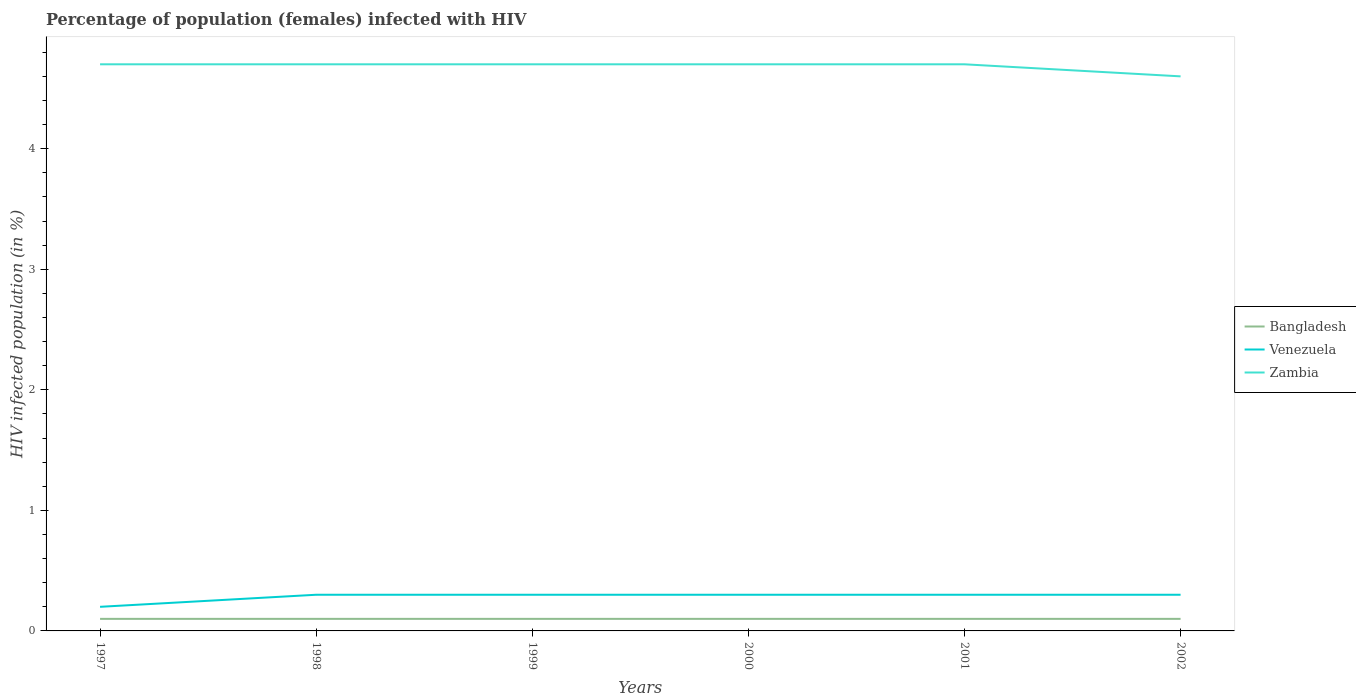How many different coloured lines are there?
Provide a succinct answer. 3. Is the number of lines equal to the number of legend labels?
Make the answer very short. Yes. Across all years, what is the maximum percentage of HIV infected female population in Venezuela?
Your response must be concise. 0.2. What is the total percentage of HIV infected female population in Venezuela in the graph?
Offer a very short reply. 0. What is the difference between the highest and the second highest percentage of HIV infected female population in Venezuela?
Ensure brevity in your answer.  0.1. Is the percentage of HIV infected female population in Venezuela strictly greater than the percentage of HIV infected female population in Bangladesh over the years?
Provide a short and direct response. No. How many years are there in the graph?
Offer a terse response. 6. Are the values on the major ticks of Y-axis written in scientific E-notation?
Give a very brief answer. No. Does the graph contain any zero values?
Offer a terse response. No. Does the graph contain grids?
Provide a succinct answer. No. How are the legend labels stacked?
Offer a very short reply. Vertical. What is the title of the graph?
Provide a short and direct response. Percentage of population (females) infected with HIV. Does "Cyprus" appear as one of the legend labels in the graph?
Make the answer very short. No. What is the label or title of the X-axis?
Your answer should be compact. Years. What is the label or title of the Y-axis?
Offer a terse response. HIV infected population (in %). What is the HIV infected population (in %) of Zambia in 1997?
Your response must be concise. 4.7. What is the HIV infected population (in %) of Bangladesh in 1998?
Your answer should be compact. 0.1. What is the HIV infected population (in %) in Zambia in 1998?
Offer a terse response. 4.7. What is the HIV infected population (in %) in Venezuela in 1999?
Give a very brief answer. 0.3. What is the HIV infected population (in %) in Zambia in 1999?
Ensure brevity in your answer.  4.7. What is the HIV infected population (in %) of Zambia in 2000?
Your response must be concise. 4.7. What is the HIV infected population (in %) in Bangladesh in 2001?
Your answer should be very brief. 0.1. What is the HIV infected population (in %) in Zambia in 2001?
Provide a short and direct response. 4.7. What is the HIV infected population (in %) in Venezuela in 2002?
Provide a short and direct response. 0.3. Across all years, what is the maximum HIV infected population (in %) in Bangladesh?
Provide a short and direct response. 0.1. Across all years, what is the maximum HIV infected population (in %) of Venezuela?
Your answer should be compact. 0.3. Across all years, what is the maximum HIV infected population (in %) of Zambia?
Offer a very short reply. 4.7. Across all years, what is the minimum HIV infected population (in %) in Bangladesh?
Your response must be concise. 0.1. Across all years, what is the minimum HIV infected population (in %) of Venezuela?
Give a very brief answer. 0.2. What is the total HIV infected population (in %) in Bangladesh in the graph?
Your answer should be compact. 0.6. What is the total HIV infected population (in %) of Zambia in the graph?
Ensure brevity in your answer.  28.1. What is the difference between the HIV infected population (in %) of Venezuela in 1997 and that in 1998?
Make the answer very short. -0.1. What is the difference between the HIV infected population (in %) in Zambia in 1997 and that in 1998?
Your answer should be compact. 0. What is the difference between the HIV infected population (in %) of Bangladesh in 1997 and that in 1999?
Your response must be concise. 0. What is the difference between the HIV infected population (in %) in Bangladesh in 1997 and that in 2000?
Keep it short and to the point. 0. What is the difference between the HIV infected population (in %) of Venezuela in 1997 and that in 2000?
Offer a terse response. -0.1. What is the difference between the HIV infected population (in %) in Bangladesh in 1997 and that in 2001?
Offer a very short reply. 0. What is the difference between the HIV infected population (in %) of Zambia in 1997 and that in 2001?
Provide a short and direct response. 0. What is the difference between the HIV infected population (in %) of Bangladesh in 1997 and that in 2002?
Provide a short and direct response. 0. What is the difference between the HIV infected population (in %) in Venezuela in 1997 and that in 2002?
Your answer should be very brief. -0.1. What is the difference between the HIV infected population (in %) in Zambia in 1997 and that in 2002?
Your response must be concise. 0.1. What is the difference between the HIV infected population (in %) in Bangladesh in 1998 and that in 1999?
Ensure brevity in your answer.  0. What is the difference between the HIV infected population (in %) of Venezuela in 1998 and that in 1999?
Offer a terse response. 0. What is the difference between the HIV infected population (in %) in Bangladesh in 1998 and that in 2000?
Give a very brief answer. 0. What is the difference between the HIV infected population (in %) in Zambia in 1998 and that in 2000?
Offer a terse response. 0. What is the difference between the HIV infected population (in %) in Venezuela in 1998 and that in 2001?
Ensure brevity in your answer.  0. What is the difference between the HIV infected population (in %) of Zambia in 1998 and that in 2001?
Offer a terse response. 0. What is the difference between the HIV infected population (in %) in Venezuela in 1998 and that in 2002?
Ensure brevity in your answer.  0. What is the difference between the HIV infected population (in %) of Zambia in 1998 and that in 2002?
Offer a terse response. 0.1. What is the difference between the HIV infected population (in %) in Bangladesh in 1999 and that in 2002?
Ensure brevity in your answer.  0. What is the difference between the HIV infected population (in %) of Venezuela in 1999 and that in 2002?
Your answer should be very brief. 0. What is the difference between the HIV infected population (in %) in Zambia in 2000 and that in 2002?
Make the answer very short. 0.1. What is the difference between the HIV infected population (in %) of Venezuela in 2001 and that in 2002?
Provide a short and direct response. 0. What is the difference between the HIV infected population (in %) of Bangladesh in 1997 and the HIV infected population (in %) of Venezuela in 1998?
Keep it short and to the point. -0.2. What is the difference between the HIV infected population (in %) in Venezuela in 1997 and the HIV infected population (in %) in Zambia in 1998?
Provide a short and direct response. -4.5. What is the difference between the HIV infected population (in %) of Bangladesh in 1997 and the HIV infected population (in %) of Venezuela in 1999?
Provide a short and direct response. -0.2. What is the difference between the HIV infected population (in %) of Bangladesh in 1997 and the HIV infected population (in %) of Venezuela in 2000?
Ensure brevity in your answer.  -0.2. What is the difference between the HIV infected population (in %) of Bangladesh in 1997 and the HIV infected population (in %) of Zambia in 2001?
Your answer should be compact. -4.6. What is the difference between the HIV infected population (in %) of Venezuela in 1997 and the HIV infected population (in %) of Zambia in 2002?
Make the answer very short. -4.4. What is the difference between the HIV infected population (in %) of Bangladesh in 1998 and the HIV infected population (in %) of Venezuela in 1999?
Offer a very short reply. -0.2. What is the difference between the HIV infected population (in %) of Venezuela in 1998 and the HIV infected population (in %) of Zambia in 1999?
Your answer should be very brief. -4.4. What is the difference between the HIV infected population (in %) in Bangladesh in 1998 and the HIV infected population (in %) in Zambia in 2000?
Your answer should be very brief. -4.6. What is the difference between the HIV infected population (in %) in Bangladesh in 1998 and the HIV infected population (in %) in Zambia in 2001?
Provide a short and direct response. -4.6. What is the difference between the HIV infected population (in %) of Venezuela in 1998 and the HIV infected population (in %) of Zambia in 2001?
Provide a short and direct response. -4.4. What is the difference between the HIV infected population (in %) of Bangladesh in 1998 and the HIV infected population (in %) of Zambia in 2002?
Provide a succinct answer. -4.5. What is the difference between the HIV infected population (in %) of Bangladesh in 1999 and the HIV infected population (in %) of Venezuela in 2002?
Your answer should be compact. -0.2. What is the difference between the HIV infected population (in %) in Bangladesh in 1999 and the HIV infected population (in %) in Zambia in 2002?
Give a very brief answer. -4.5. What is the difference between the HIV infected population (in %) of Venezuela in 1999 and the HIV infected population (in %) of Zambia in 2002?
Your answer should be very brief. -4.3. What is the difference between the HIV infected population (in %) of Bangladesh in 2000 and the HIV infected population (in %) of Zambia in 2001?
Provide a succinct answer. -4.6. What is the difference between the HIV infected population (in %) in Venezuela in 2000 and the HIV infected population (in %) in Zambia in 2001?
Provide a succinct answer. -4.4. What is the difference between the HIV infected population (in %) of Bangladesh in 2001 and the HIV infected population (in %) of Venezuela in 2002?
Provide a succinct answer. -0.2. What is the difference between the HIV infected population (in %) in Venezuela in 2001 and the HIV infected population (in %) in Zambia in 2002?
Make the answer very short. -4.3. What is the average HIV infected population (in %) of Bangladesh per year?
Provide a succinct answer. 0.1. What is the average HIV infected population (in %) of Venezuela per year?
Ensure brevity in your answer.  0.28. What is the average HIV infected population (in %) of Zambia per year?
Provide a short and direct response. 4.68. In the year 1997, what is the difference between the HIV infected population (in %) of Bangladesh and HIV infected population (in %) of Venezuela?
Your answer should be compact. -0.1. In the year 1997, what is the difference between the HIV infected population (in %) of Venezuela and HIV infected population (in %) of Zambia?
Make the answer very short. -4.5. In the year 1998, what is the difference between the HIV infected population (in %) of Bangladesh and HIV infected population (in %) of Venezuela?
Provide a succinct answer. -0.2. In the year 2000, what is the difference between the HIV infected population (in %) of Bangladesh and HIV infected population (in %) of Venezuela?
Ensure brevity in your answer.  -0.2. In the year 2000, what is the difference between the HIV infected population (in %) in Venezuela and HIV infected population (in %) in Zambia?
Keep it short and to the point. -4.4. In the year 2002, what is the difference between the HIV infected population (in %) of Bangladesh and HIV infected population (in %) of Venezuela?
Your response must be concise. -0.2. In the year 2002, what is the difference between the HIV infected population (in %) of Bangladesh and HIV infected population (in %) of Zambia?
Provide a succinct answer. -4.5. What is the ratio of the HIV infected population (in %) in Zambia in 1997 to that in 1998?
Provide a short and direct response. 1. What is the ratio of the HIV infected population (in %) of Venezuela in 1997 to that in 1999?
Your answer should be very brief. 0.67. What is the ratio of the HIV infected population (in %) of Zambia in 1997 to that in 1999?
Give a very brief answer. 1. What is the ratio of the HIV infected population (in %) in Bangladesh in 1997 to that in 2000?
Ensure brevity in your answer.  1. What is the ratio of the HIV infected population (in %) in Venezuela in 1997 to that in 2000?
Offer a very short reply. 0.67. What is the ratio of the HIV infected population (in %) of Zambia in 1997 to that in 2000?
Make the answer very short. 1. What is the ratio of the HIV infected population (in %) in Bangladesh in 1997 to that in 2001?
Provide a short and direct response. 1. What is the ratio of the HIV infected population (in %) of Bangladesh in 1997 to that in 2002?
Make the answer very short. 1. What is the ratio of the HIV infected population (in %) in Zambia in 1997 to that in 2002?
Give a very brief answer. 1.02. What is the ratio of the HIV infected population (in %) in Bangladesh in 1998 to that in 1999?
Provide a succinct answer. 1. What is the ratio of the HIV infected population (in %) of Zambia in 1998 to that in 1999?
Provide a short and direct response. 1. What is the ratio of the HIV infected population (in %) of Venezuela in 1998 to that in 2000?
Offer a terse response. 1. What is the ratio of the HIV infected population (in %) of Zambia in 1998 to that in 2000?
Provide a short and direct response. 1. What is the ratio of the HIV infected population (in %) of Zambia in 1998 to that in 2001?
Provide a short and direct response. 1. What is the ratio of the HIV infected population (in %) of Venezuela in 1998 to that in 2002?
Offer a terse response. 1. What is the ratio of the HIV infected population (in %) in Zambia in 1998 to that in 2002?
Make the answer very short. 1.02. What is the ratio of the HIV infected population (in %) in Zambia in 1999 to that in 2001?
Ensure brevity in your answer.  1. What is the ratio of the HIV infected population (in %) of Bangladesh in 1999 to that in 2002?
Your response must be concise. 1. What is the ratio of the HIV infected population (in %) in Venezuela in 1999 to that in 2002?
Offer a very short reply. 1. What is the ratio of the HIV infected population (in %) of Zambia in 1999 to that in 2002?
Your answer should be compact. 1.02. What is the ratio of the HIV infected population (in %) of Venezuela in 2000 to that in 2001?
Provide a succinct answer. 1. What is the ratio of the HIV infected population (in %) of Venezuela in 2000 to that in 2002?
Your response must be concise. 1. What is the ratio of the HIV infected population (in %) in Zambia in 2000 to that in 2002?
Provide a succinct answer. 1.02. What is the ratio of the HIV infected population (in %) of Bangladesh in 2001 to that in 2002?
Your answer should be very brief. 1. What is the ratio of the HIV infected population (in %) of Zambia in 2001 to that in 2002?
Give a very brief answer. 1.02. What is the difference between the highest and the second highest HIV infected population (in %) of Bangladesh?
Provide a succinct answer. 0. What is the difference between the highest and the second highest HIV infected population (in %) of Venezuela?
Offer a terse response. 0. 